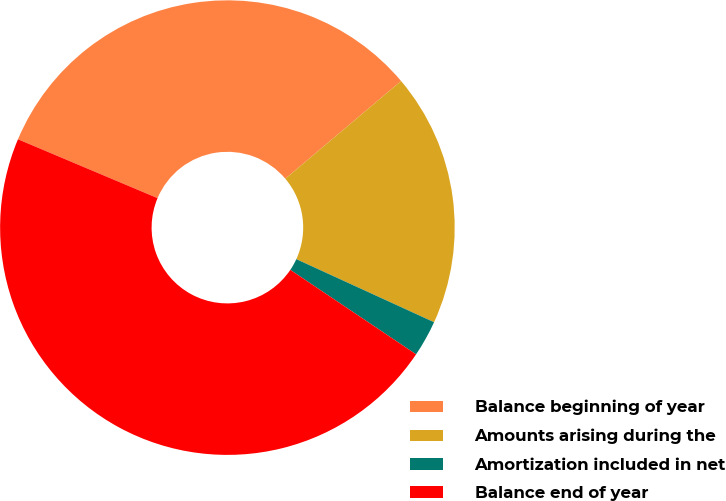<chart> <loc_0><loc_0><loc_500><loc_500><pie_chart><fcel>Balance beginning of year<fcel>Amounts arising during the<fcel>Amortization included in net<fcel>Balance end of year<nl><fcel>32.49%<fcel>17.99%<fcel>2.58%<fcel>46.94%<nl></chart> 